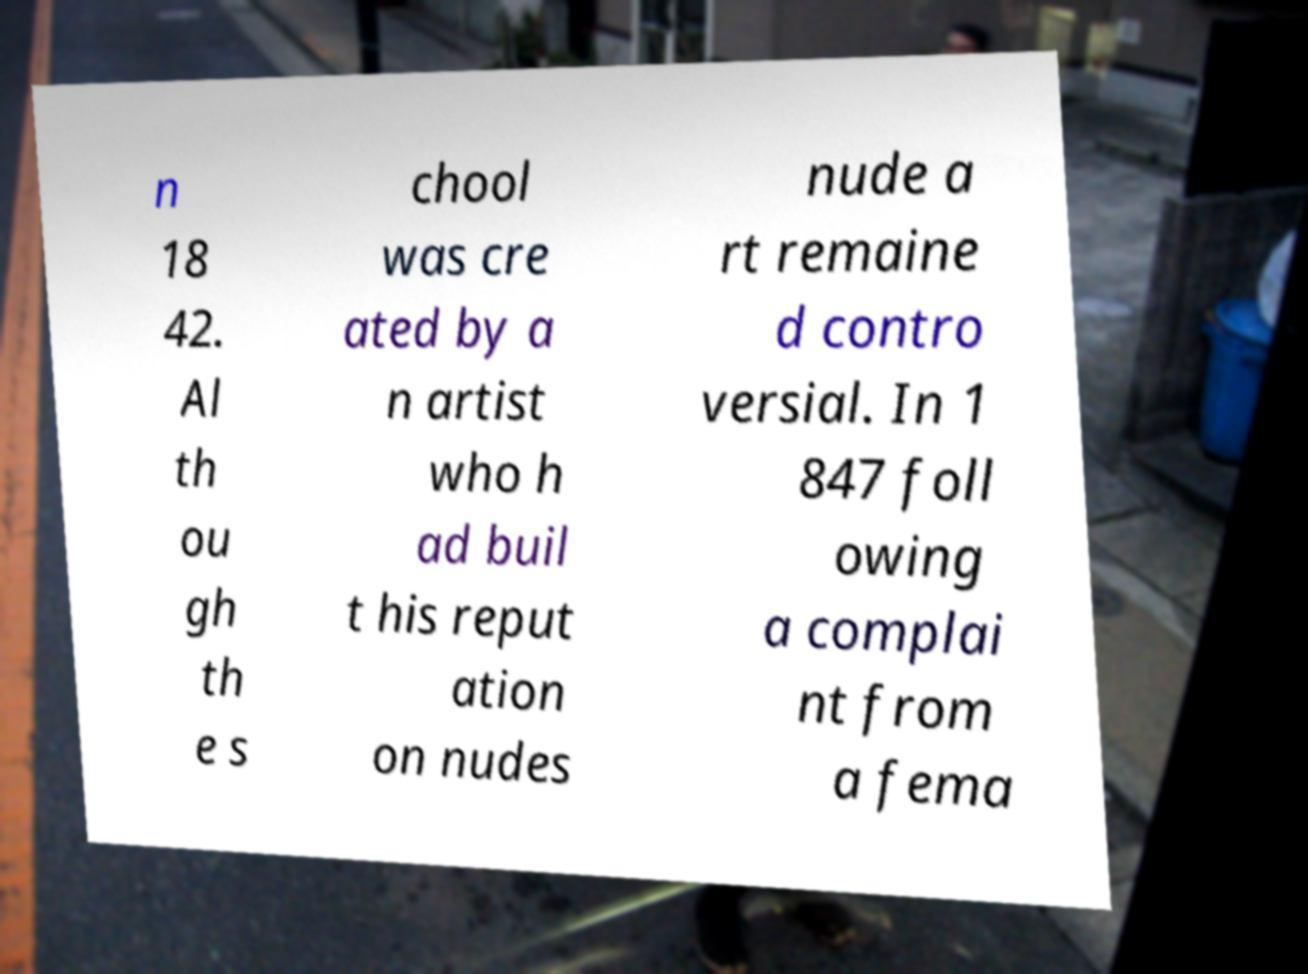Please read and relay the text visible in this image. What does it say? n 18 42. Al th ou gh th e s chool was cre ated by a n artist who h ad buil t his reput ation on nudes nude a rt remaine d contro versial. In 1 847 foll owing a complai nt from a fema 